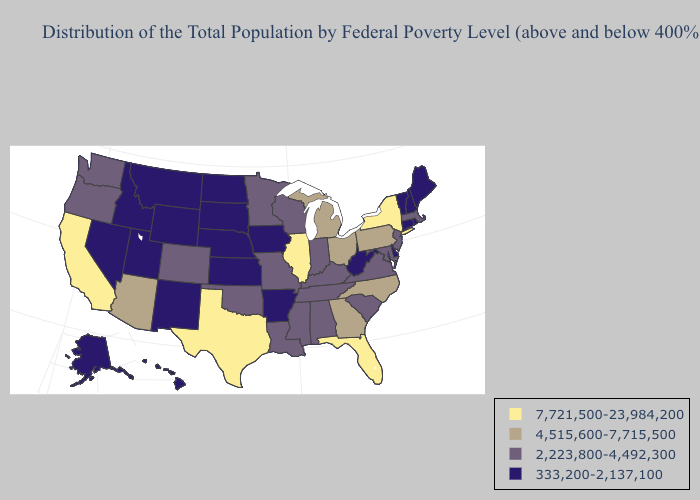What is the highest value in the West ?
Concise answer only. 7,721,500-23,984,200. Does the map have missing data?
Give a very brief answer. No. Does Massachusetts have the highest value in the Northeast?
Write a very short answer. No. What is the highest value in the South ?
Keep it brief. 7,721,500-23,984,200. Does New Mexico have the lowest value in the USA?
Be succinct. Yes. Which states have the lowest value in the MidWest?
Answer briefly. Iowa, Kansas, Nebraska, North Dakota, South Dakota. Name the states that have a value in the range 333,200-2,137,100?
Keep it brief. Alaska, Arkansas, Connecticut, Delaware, Hawaii, Idaho, Iowa, Kansas, Maine, Montana, Nebraska, Nevada, New Hampshire, New Mexico, North Dakota, Rhode Island, South Dakota, Utah, Vermont, West Virginia, Wyoming. Does New York have the highest value in the USA?
Concise answer only. Yes. Name the states that have a value in the range 7,721,500-23,984,200?
Write a very short answer. California, Florida, Illinois, New York, Texas. What is the highest value in the MidWest ?
Answer briefly. 7,721,500-23,984,200. Name the states that have a value in the range 4,515,600-7,715,500?
Short answer required. Arizona, Georgia, Michigan, North Carolina, Ohio, Pennsylvania. Name the states that have a value in the range 4,515,600-7,715,500?
Keep it brief. Arizona, Georgia, Michigan, North Carolina, Ohio, Pennsylvania. What is the lowest value in the USA?
Concise answer only. 333,200-2,137,100. What is the value of New Jersey?
Write a very short answer. 2,223,800-4,492,300. Does the map have missing data?
Keep it brief. No. 